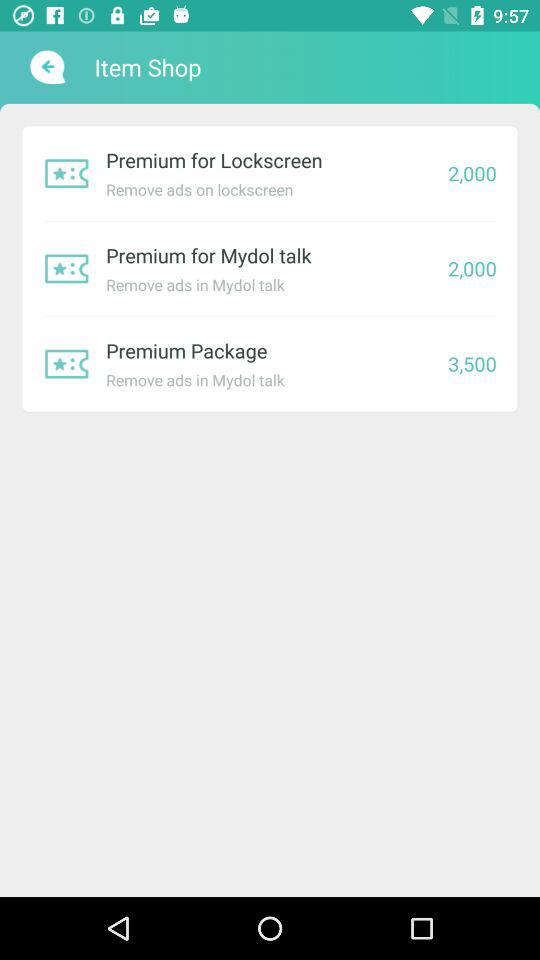What is the price of the "Premium for Lockscreen"? The price is 2,000. 